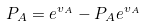Convert formula to latex. <formula><loc_0><loc_0><loc_500><loc_500>P _ { A } = e ^ { v _ { A } } - P _ { A } e ^ { v _ { A } }</formula> 